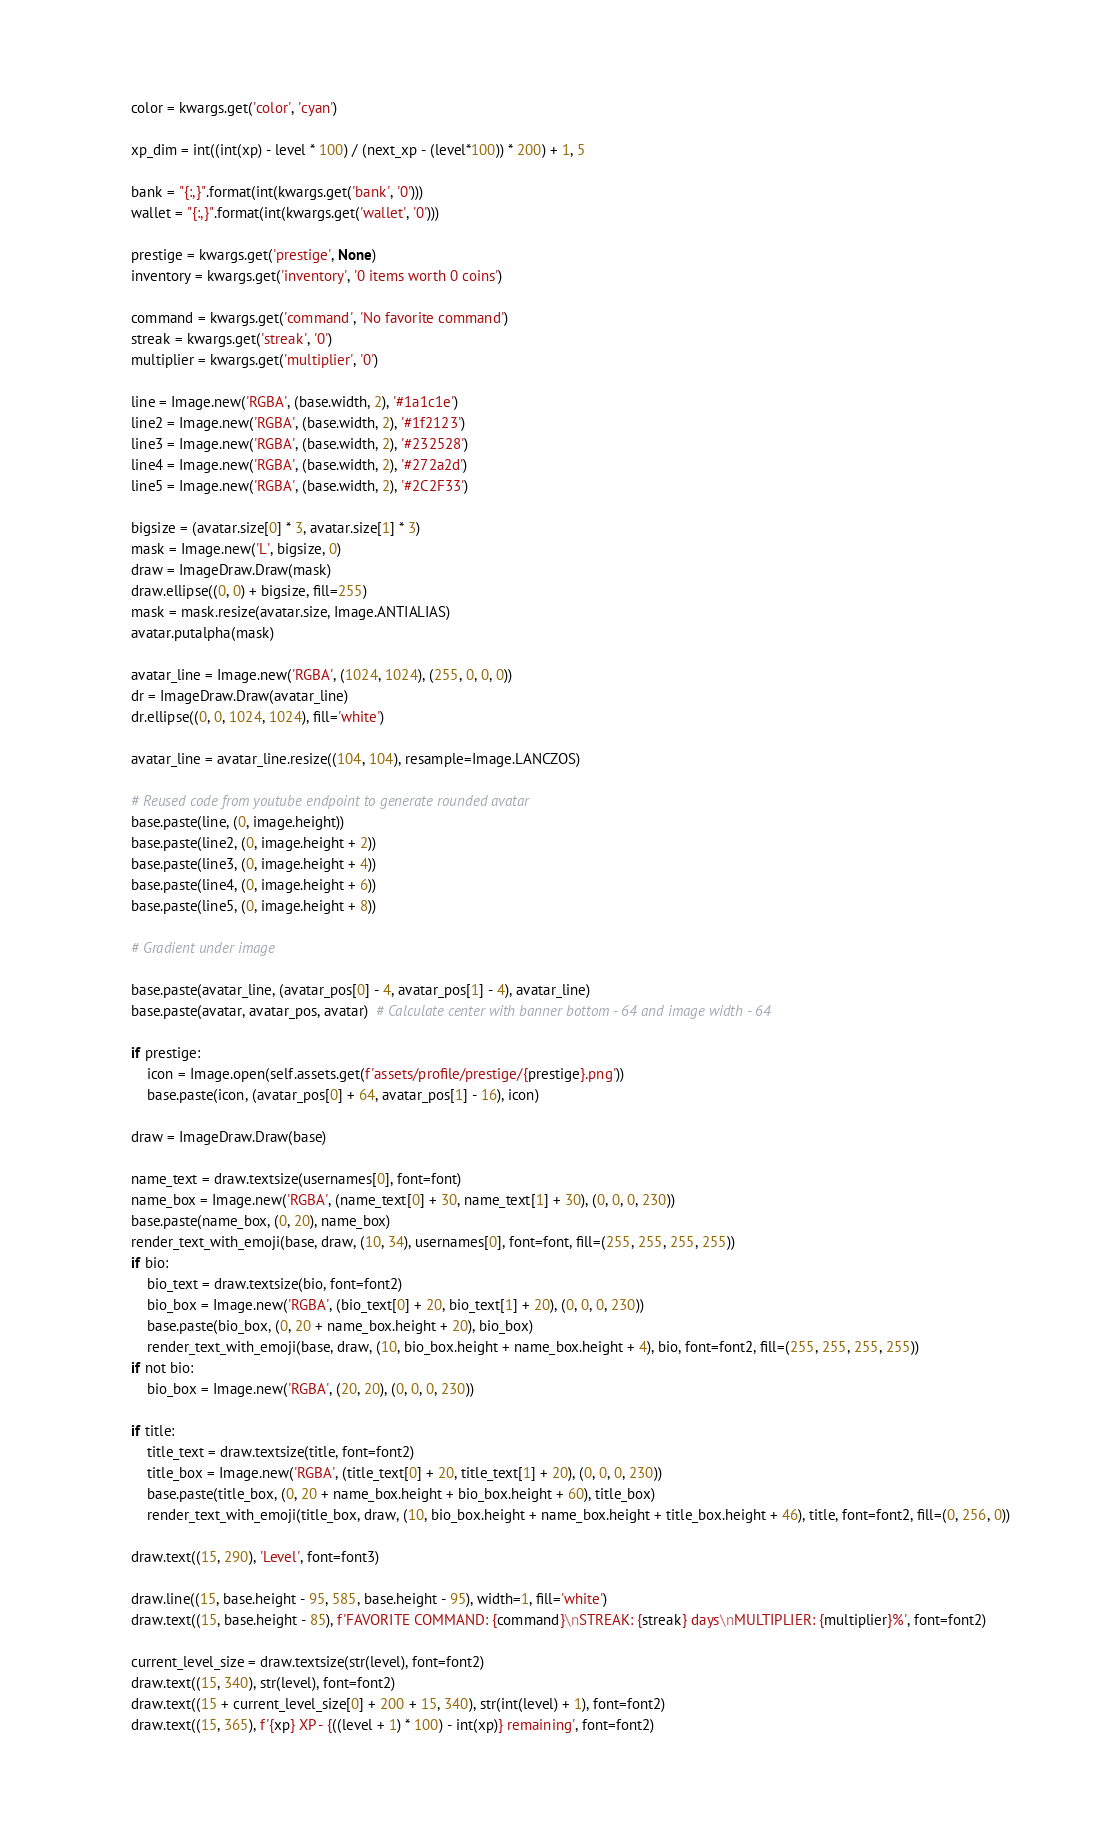<code> <loc_0><loc_0><loc_500><loc_500><_Python_>
        color = kwargs.get('color', 'cyan')

        xp_dim = int((int(xp) - level * 100) / (next_xp - (level*100)) * 200) + 1, 5

        bank = "{:,}".format(int(kwargs.get('bank', '0')))
        wallet = "{:,}".format(int(kwargs.get('wallet', '0')))

        prestige = kwargs.get('prestige', None)
        inventory = kwargs.get('inventory', '0 items worth 0 coins')

        command = kwargs.get('command', 'No favorite command')
        streak = kwargs.get('streak', '0')
        multiplier = kwargs.get('multiplier', '0')

        line = Image.new('RGBA', (base.width, 2), '#1a1c1e')
        line2 = Image.new('RGBA', (base.width, 2), '#1f2123')
        line3 = Image.new('RGBA', (base.width, 2), '#232528')
        line4 = Image.new('RGBA', (base.width, 2), '#272a2d')
        line5 = Image.new('RGBA', (base.width, 2), '#2C2F33')

        bigsize = (avatar.size[0] * 3, avatar.size[1] * 3)
        mask = Image.new('L', bigsize, 0)
        draw = ImageDraw.Draw(mask)
        draw.ellipse((0, 0) + bigsize, fill=255)
        mask = mask.resize(avatar.size, Image.ANTIALIAS)
        avatar.putalpha(mask)

        avatar_line = Image.new('RGBA', (1024, 1024), (255, 0, 0, 0))
        dr = ImageDraw.Draw(avatar_line)
        dr.ellipse((0, 0, 1024, 1024), fill='white')

        avatar_line = avatar_line.resize((104, 104), resample=Image.LANCZOS)

        # Reused code from youtube endpoint to generate rounded avatar
        base.paste(line, (0, image.height))
        base.paste(line2, (0, image.height + 2))
        base.paste(line3, (0, image.height + 4))
        base.paste(line4, (0, image.height + 6))
        base.paste(line5, (0, image.height + 8))

        # Gradient under image

        base.paste(avatar_line, (avatar_pos[0] - 4, avatar_pos[1] - 4), avatar_line)
        base.paste(avatar, avatar_pos, avatar)  # Calculate center with banner bottom - 64 and image width - 64

        if prestige:
            icon = Image.open(self.assets.get(f'assets/profile/prestige/{prestige}.png'))
            base.paste(icon, (avatar_pos[0] + 64, avatar_pos[1] - 16), icon)

        draw = ImageDraw.Draw(base)

        name_text = draw.textsize(usernames[0], font=font)
        name_box = Image.new('RGBA', (name_text[0] + 30, name_text[1] + 30), (0, 0, 0, 230))
        base.paste(name_box, (0, 20), name_box)
        render_text_with_emoji(base, draw, (10, 34), usernames[0], font=font, fill=(255, 255, 255, 255))
        if bio:
            bio_text = draw.textsize(bio, font=font2)
            bio_box = Image.new('RGBA', (bio_text[0] + 20, bio_text[1] + 20), (0, 0, 0, 230))
            base.paste(bio_box, (0, 20 + name_box.height + 20), bio_box)
            render_text_with_emoji(base, draw, (10, bio_box.height + name_box.height + 4), bio, font=font2, fill=(255, 255, 255, 255))
        if not bio:
            bio_box = Image.new('RGBA', (20, 20), (0, 0, 0, 230))

        if title:
            title_text = draw.textsize(title, font=font2)
            title_box = Image.new('RGBA', (title_text[0] + 20, title_text[1] + 20), (0, 0, 0, 230))
            base.paste(title_box, (0, 20 + name_box.height + bio_box.height + 60), title_box)
            render_text_with_emoji(title_box, draw, (10, bio_box.height + name_box.height + title_box.height + 46), title, font=font2, fill=(0, 256, 0))

        draw.text((15, 290), 'Level', font=font3)

        draw.line((15, base.height - 95, 585, base.height - 95), width=1, fill='white')
        draw.text((15, base.height - 85), f'FAVORITE COMMAND: {command}\nSTREAK: {streak} days\nMULTIPLIER: {multiplier}%', font=font2)

        current_level_size = draw.textsize(str(level), font=font2)
        draw.text((15, 340), str(level), font=font2)
        draw.text((15 + current_level_size[0] + 200 + 15, 340), str(int(level) + 1), font=font2)
        draw.text((15, 365), f'{xp} XP - {((level + 1) * 100) - int(xp)} remaining', font=font2)
</code> 